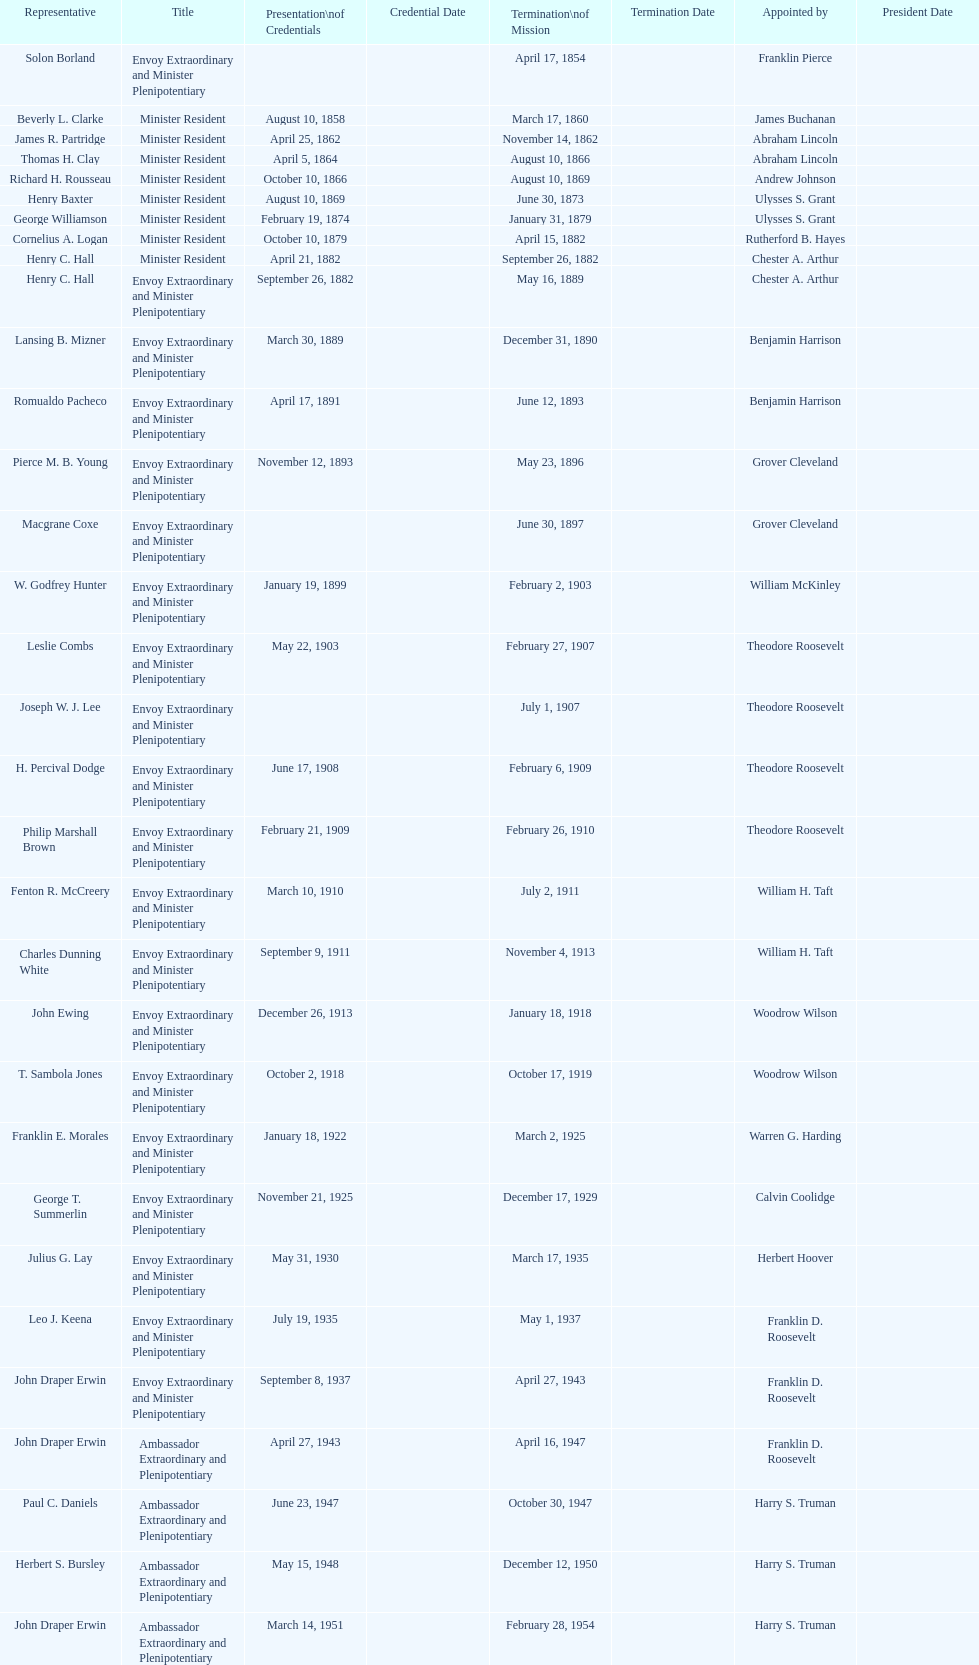Is solon borland a delegate? Yes. 